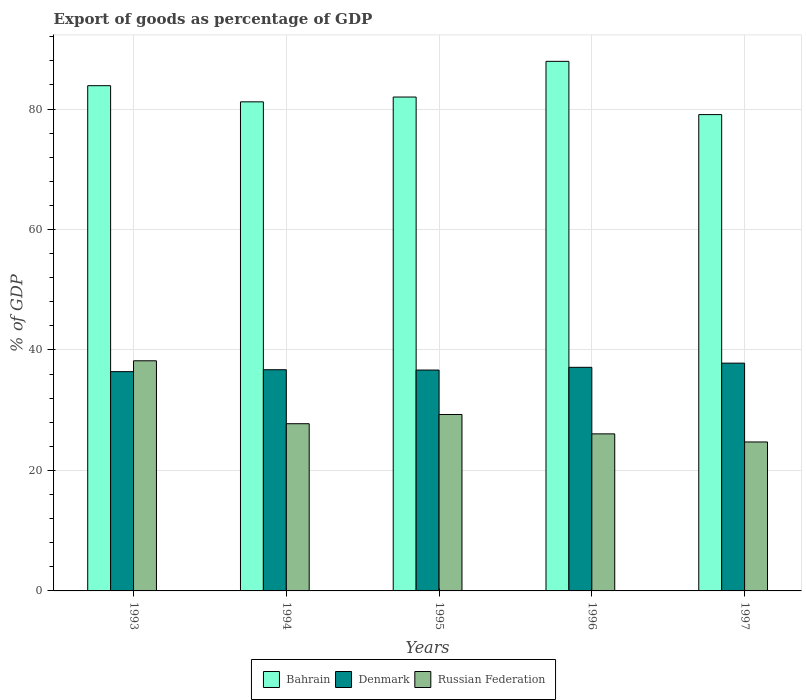How many different coloured bars are there?
Your answer should be very brief. 3. How many groups of bars are there?
Your answer should be compact. 5. What is the export of goods as percentage of GDP in Bahrain in 1993?
Provide a succinct answer. 83.87. Across all years, what is the maximum export of goods as percentage of GDP in Russian Federation?
Ensure brevity in your answer.  38.2. Across all years, what is the minimum export of goods as percentage of GDP in Russian Federation?
Offer a very short reply. 24.73. In which year was the export of goods as percentage of GDP in Denmark minimum?
Give a very brief answer. 1993. What is the total export of goods as percentage of GDP in Bahrain in the graph?
Ensure brevity in your answer.  414.05. What is the difference between the export of goods as percentage of GDP in Bahrain in 1993 and that in 1996?
Ensure brevity in your answer.  -4.04. What is the difference between the export of goods as percentage of GDP in Denmark in 1997 and the export of goods as percentage of GDP in Bahrain in 1995?
Your response must be concise. -44.18. What is the average export of goods as percentage of GDP in Russian Federation per year?
Ensure brevity in your answer.  29.21. In the year 1996, what is the difference between the export of goods as percentage of GDP in Russian Federation and export of goods as percentage of GDP in Denmark?
Offer a very short reply. -11.05. What is the ratio of the export of goods as percentage of GDP in Denmark in 1994 to that in 1997?
Make the answer very short. 0.97. What is the difference between the highest and the second highest export of goods as percentage of GDP in Bahrain?
Provide a succinct answer. 4.04. What is the difference between the highest and the lowest export of goods as percentage of GDP in Russian Federation?
Your response must be concise. 13.47. Is the sum of the export of goods as percentage of GDP in Russian Federation in 1994 and 1996 greater than the maximum export of goods as percentage of GDP in Bahrain across all years?
Offer a very short reply. No. What does the 1st bar from the left in 1996 represents?
Your answer should be compact. Bahrain. What does the 2nd bar from the right in 1996 represents?
Offer a terse response. Denmark. Is it the case that in every year, the sum of the export of goods as percentage of GDP in Denmark and export of goods as percentage of GDP in Bahrain is greater than the export of goods as percentage of GDP in Russian Federation?
Your answer should be compact. Yes. How many bars are there?
Your answer should be very brief. 15. Are all the bars in the graph horizontal?
Provide a succinct answer. No. What is the difference between two consecutive major ticks on the Y-axis?
Offer a terse response. 20. How are the legend labels stacked?
Provide a short and direct response. Horizontal. What is the title of the graph?
Offer a very short reply. Export of goods as percentage of GDP. Does "Singapore" appear as one of the legend labels in the graph?
Your answer should be compact. No. What is the label or title of the Y-axis?
Your response must be concise. % of GDP. What is the % of GDP in Bahrain in 1993?
Your response must be concise. 83.87. What is the % of GDP in Denmark in 1993?
Offer a very short reply. 36.4. What is the % of GDP in Russian Federation in 1993?
Make the answer very short. 38.2. What is the % of GDP of Bahrain in 1994?
Your answer should be very brief. 81.19. What is the % of GDP of Denmark in 1994?
Your response must be concise. 36.72. What is the % of GDP in Russian Federation in 1994?
Offer a terse response. 27.76. What is the % of GDP of Bahrain in 1995?
Your response must be concise. 81.99. What is the % of GDP in Denmark in 1995?
Your response must be concise. 36.67. What is the % of GDP in Russian Federation in 1995?
Your response must be concise. 29.29. What is the % of GDP of Bahrain in 1996?
Make the answer very short. 87.91. What is the % of GDP in Denmark in 1996?
Your answer should be compact. 37.12. What is the % of GDP of Russian Federation in 1996?
Make the answer very short. 26.07. What is the % of GDP in Bahrain in 1997?
Offer a terse response. 79.08. What is the % of GDP of Denmark in 1997?
Your answer should be very brief. 37.81. What is the % of GDP in Russian Federation in 1997?
Ensure brevity in your answer.  24.73. Across all years, what is the maximum % of GDP in Bahrain?
Keep it short and to the point. 87.91. Across all years, what is the maximum % of GDP in Denmark?
Give a very brief answer. 37.81. Across all years, what is the maximum % of GDP in Russian Federation?
Give a very brief answer. 38.2. Across all years, what is the minimum % of GDP in Bahrain?
Make the answer very short. 79.08. Across all years, what is the minimum % of GDP in Denmark?
Provide a short and direct response. 36.4. Across all years, what is the minimum % of GDP in Russian Federation?
Your response must be concise. 24.73. What is the total % of GDP of Bahrain in the graph?
Keep it short and to the point. 414.05. What is the total % of GDP of Denmark in the graph?
Provide a succinct answer. 184.72. What is the total % of GDP of Russian Federation in the graph?
Your answer should be compact. 146.06. What is the difference between the % of GDP of Bahrain in 1993 and that in 1994?
Your answer should be compact. 2.68. What is the difference between the % of GDP of Denmark in 1993 and that in 1994?
Provide a succinct answer. -0.32. What is the difference between the % of GDP in Russian Federation in 1993 and that in 1994?
Your response must be concise. 10.45. What is the difference between the % of GDP of Bahrain in 1993 and that in 1995?
Offer a terse response. 1.88. What is the difference between the % of GDP in Denmark in 1993 and that in 1995?
Make the answer very short. -0.26. What is the difference between the % of GDP in Russian Federation in 1993 and that in 1995?
Give a very brief answer. 8.92. What is the difference between the % of GDP in Bahrain in 1993 and that in 1996?
Your answer should be very brief. -4.04. What is the difference between the % of GDP in Denmark in 1993 and that in 1996?
Give a very brief answer. -0.72. What is the difference between the % of GDP in Russian Federation in 1993 and that in 1996?
Make the answer very short. 12.13. What is the difference between the % of GDP in Bahrain in 1993 and that in 1997?
Offer a very short reply. 4.8. What is the difference between the % of GDP in Denmark in 1993 and that in 1997?
Provide a succinct answer. -1.41. What is the difference between the % of GDP of Russian Federation in 1993 and that in 1997?
Make the answer very short. 13.47. What is the difference between the % of GDP in Bahrain in 1994 and that in 1995?
Keep it short and to the point. -0.8. What is the difference between the % of GDP in Denmark in 1994 and that in 1995?
Keep it short and to the point. 0.05. What is the difference between the % of GDP of Russian Federation in 1994 and that in 1995?
Offer a terse response. -1.53. What is the difference between the % of GDP of Bahrain in 1994 and that in 1996?
Provide a short and direct response. -6.72. What is the difference between the % of GDP of Denmark in 1994 and that in 1996?
Provide a short and direct response. -0.4. What is the difference between the % of GDP in Russian Federation in 1994 and that in 1996?
Keep it short and to the point. 1.69. What is the difference between the % of GDP of Bahrain in 1994 and that in 1997?
Give a very brief answer. 2.12. What is the difference between the % of GDP of Denmark in 1994 and that in 1997?
Your answer should be compact. -1.09. What is the difference between the % of GDP in Russian Federation in 1994 and that in 1997?
Your response must be concise. 3.03. What is the difference between the % of GDP of Bahrain in 1995 and that in 1996?
Your answer should be compact. -5.92. What is the difference between the % of GDP in Denmark in 1995 and that in 1996?
Offer a very short reply. -0.45. What is the difference between the % of GDP of Russian Federation in 1995 and that in 1996?
Offer a very short reply. 3.22. What is the difference between the % of GDP of Bahrain in 1995 and that in 1997?
Provide a succinct answer. 2.91. What is the difference between the % of GDP in Denmark in 1995 and that in 1997?
Keep it short and to the point. -1.15. What is the difference between the % of GDP of Russian Federation in 1995 and that in 1997?
Provide a succinct answer. 4.56. What is the difference between the % of GDP in Bahrain in 1996 and that in 1997?
Give a very brief answer. 8.84. What is the difference between the % of GDP of Denmark in 1996 and that in 1997?
Make the answer very short. -0.69. What is the difference between the % of GDP in Russian Federation in 1996 and that in 1997?
Keep it short and to the point. 1.34. What is the difference between the % of GDP of Bahrain in 1993 and the % of GDP of Denmark in 1994?
Your response must be concise. 47.16. What is the difference between the % of GDP of Bahrain in 1993 and the % of GDP of Russian Federation in 1994?
Offer a terse response. 56.12. What is the difference between the % of GDP of Denmark in 1993 and the % of GDP of Russian Federation in 1994?
Your answer should be very brief. 8.64. What is the difference between the % of GDP in Bahrain in 1993 and the % of GDP in Denmark in 1995?
Your answer should be compact. 47.21. What is the difference between the % of GDP in Bahrain in 1993 and the % of GDP in Russian Federation in 1995?
Offer a very short reply. 54.59. What is the difference between the % of GDP in Denmark in 1993 and the % of GDP in Russian Federation in 1995?
Provide a short and direct response. 7.11. What is the difference between the % of GDP in Bahrain in 1993 and the % of GDP in Denmark in 1996?
Your response must be concise. 46.76. What is the difference between the % of GDP in Bahrain in 1993 and the % of GDP in Russian Federation in 1996?
Give a very brief answer. 57.8. What is the difference between the % of GDP in Denmark in 1993 and the % of GDP in Russian Federation in 1996?
Give a very brief answer. 10.33. What is the difference between the % of GDP of Bahrain in 1993 and the % of GDP of Denmark in 1997?
Your answer should be compact. 46.06. What is the difference between the % of GDP in Bahrain in 1993 and the % of GDP in Russian Federation in 1997?
Your answer should be very brief. 59.14. What is the difference between the % of GDP of Denmark in 1993 and the % of GDP of Russian Federation in 1997?
Provide a short and direct response. 11.67. What is the difference between the % of GDP in Bahrain in 1994 and the % of GDP in Denmark in 1995?
Ensure brevity in your answer.  44.53. What is the difference between the % of GDP in Bahrain in 1994 and the % of GDP in Russian Federation in 1995?
Offer a very short reply. 51.9. What is the difference between the % of GDP of Denmark in 1994 and the % of GDP of Russian Federation in 1995?
Provide a short and direct response. 7.43. What is the difference between the % of GDP in Bahrain in 1994 and the % of GDP in Denmark in 1996?
Offer a very short reply. 44.07. What is the difference between the % of GDP of Bahrain in 1994 and the % of GDP of Russian Federation in 1996?
Your answer should be very brief. 55.12. What is the difference between the % of GDP in Denmark in 1994 and the % of GDP in Russian Federation in 1996?
Make the answer very short. 10.65. What is the difference between the % of GDP of Bahrain in 1994 and the % of GDP of Denmark in 1997?
Make the answer very short. 43.38. What is the difference between the % of GDP in Bahrain in 1994 and the % of GDP in Russian Federation in 1997?
Your answer should be very brief. 56.46. What is the difference between the % of GDP in Denmark in 1994 and the % of GDP in Russian Federation in 1997?
Provide a succinct answer. 11.99. What is the difference between the % of GDP of Bahrain in 1995 and the % of GDP of Denmark in 1996?
Make the answer very short. 44.87. What is the difference between the % of GDP in Bahrain in 1995 and the % of GDP in Russian Federation in 1996?
Offer a terse response. 55.92. What is the difference between the % of GDP in Denmark in 1995 and the % of GDP in Russian Federation in 1996?
Make the answer very short. 10.59. What is the difference between the % of GDP in Bahrain in 1995 and the % of GDP in Denmark in 1997?
Your response must be concise. 44.18. What is the difference between the % of GDP of Bahrain in 1995 and the % of GDP of Russian Federation in 1997?
Your response must be concise. 57.26. What is the difference between the % of GDP in Denmark in 1995 and the % of GDP in Russian Federation in 1997?
Provide a short and direct response. 11.94. What is the difference between the % of GDP of Bahrain in 1996 and the % of GDP of Denmark in 1997?
Your response must be concise. 50.1. What is the difference between the % of GDP of Bahrain in 1996 and the % of GDP of Russian Federation in 1997?
Your response must be concise. 63.18. What is the difference between the % of GDP in Denmark in 1996 and the % of GDP in Russian Federation in 1997?
Provide a short and direct response. 12.39. What is the average % of GDP in Bahrain per year?
Give a very brief answer. 82.81. What is the average % of GDP of Denmark per year?
Your answer should be compact. 36.94. What is the average % of GDP in Russian Federation per year?
Offer a very short reply. 29.21. In the year 1993, what is the difference between the % of GDP in Bahrain and % of GDP in Denmark?
Provide a succinct answer. 47.47. In the year 1993, what is the difference between the % of GDP in Bahrain and % of GDP in Russian Federation?
Your answer should be very brief. 45.67. In the year 1993, what is the difference between the % of GDP of Denmark and % of GDP of Russian Federation?
Your response must be concise. -1.8. In the year 1994, what is the difference between the % of GDP of Bahrain and % of GDP of Denmark?
Offer a very short reply. 44.47. In the year 1994, what is the difference between the % of GDP in Bahrain and % of GDP in Russian Federation?
Give a very brief answer. 53.43. In the year 1994, what is the difference between the % of GDP in Denmark and % of GDP in Russian Federation?
Your response must be concise. 8.96. In the year 1995, what is the difference between the % of GDP of Bahrain and % of GDP of Denmark?
Your answer should be very brief. 45.32. In the year 1995, what is the difference between the % of GDP of Bahrain and % of GDP of Russian Federation?
Provide a short and direct response. 52.7. In the year 1995, what is the difference between the % of GDP in Denmark and % of GDP in Russian Federation?
Make the answer very short. 7.38. In the year 1996, what is the difference between the % of GDP in Bahrain and % of GDP in Denmark?
Give a very brief answer. 50.79. In the year 1996, what is the difference between the % of GDP in Bahrain and % of GDP in Russian Federation?
Ensure brevity in your answer.  61.84. In the year 1996, what is the difference between the % of GDP in Denmark and % of GDP in Russian Federation?
Keep it short and to the point. 11.05. In the year 1997, what is the difference between the % of GDP in Bahrain and % of GDP in Denmark?
Make the answer very short. 41.27. In the year 1997, what is the difference between the % of GDP in Bahrain and % of GDP in Russian Federation?
Give a very brief answer. 54.35. In the year 1997, what is the difference between the % of GDP of Denmark and % of GDP of Russian Federation?
Provide a short and direct response. 13.08. What is the ratio of the % of GDP of Bahrain in 1993 to that in 1994?
Your answer should be compact. 1.03. What is the ratio of the % of GDP of Russian Federation in 1993 to that in 1994?
Your response must be concise. 1.38. What is the ratio of the % of GDP in Bahrain in 1993 to that in 1995?
Offer a very short reply. 1.02. What is the ratio of the % of GDP in Denmark in 1993 to that in 1995?
Give a very brief answer. 0.99. What is the ratio of the % of GDP of Russian Federation in 1993 to that in 1995?
Keep it short and to the point. 1.3. What is the ratio of the % of GDP of Bahrain in 1993 to that in 1996?
Offer a terse response. 0.95. What is the ratio of the % of GDP in Denmark in 1993 to that in 1996?
Make the answer very short. 0.98. What is the ratio of the % of GDP of Russian Federation in 1993 to that in 1996?
Your response must be concise. 1.47. What is the ratio of the % of GDP of Bahrain in 1993 to that in 1997?
Provide a succinct answer. 1.06. What is the ratio of the % of GDP in Denmark in 1993 to that in 1997?
Ensure brevity in your answer.  0.96. What is the ratio of the % of GDP in Russian Federation in 1993 to that in 1997?
Make the answer very short. 1.54. What is the ratio of the % of GDP of Bahrain in 1994 to that in 1995?
Your response must be concise. 0.99. What is the ratio of the % of GDP of Denmark in 1994 to that in 1995?
Provide a short and direct response. 1. What is the ratio of the % of GDP of Russian Federation in 1994 to that in 1995?
Your answer should be very brief. 0.95. What is the ratio of the % of GDP of Bahrain in 1994 to that in 1996?
Ensure brevity in your answer.  0.92. What is the ratio of the % of GDP of Russian Federation in 1994 to that in 1996?
Give a very brief answer. 1.06. What is the ratio of the % of GDP in Bahrain in 1994 to that in 1997?
Make the answer very short. 1.03. What is the ratio of the % of GDP of Denmark in 1994 to that in 1997?
Offer a terse response. 0.97. What is the ratio of the % of GDP in Russian Federation in 1994 to that in 1997?
Make the answer very short. 1.12. What is the ratio of the % of GDP in Bahrain in 1995 to that in 1996?
Keep it short and to the point. 0.93. What is the ratio of the % of GDP in Denmark in 1995 to that in 1996?
Provide a short and direct response. 0.99. What is the ratio of the % of GDP in Russian Federation in 1995 to that in 1996?
Keep it short and to the point. 1.12. What is the ratio of the % of GDP in Bahrain in 1995 to that in 1997?
Your answer should be very brief. 1.04. What is the ratio of the % of GDP in Denmark in 1995 to that in 1997?
Offer a terse response. 0.97. What is the ratio of the % of GDP in Russian Federation in 1995 to that in 1997?
Provide a succinct answer. 1.18. What is the ratio of the % of GDP of Bahrain in 1996 to that in 1997?
Provide a short and direct response. 1.11. What is the ratio of the % of GDP of Denmark in 1996 to that in 1997?
Your answer should be compact. 0.98. What is the ratio of the % of GDP in Russian Federation in 1996 to that in 1997?
Provide a short and direct response. 1.05. What is the difference between the highest and the second highest % of GDP of Bahrain?
Your answer should be very brief. 4.04. What is the difference between the highest and the second highest % of GDP of Denmark?
Keep it short and to the point. 0.69. What is the difference between the highest and the second highest % of GDP in Russian Federation?
Keep it short and to the point. 8.92. What is the difference between the highest and the lowest % of GDP of Bahrain?
Provide a short and direct response. 8.84. What is the difference between the highest and the lowest % of GDP of Denmark?
Offer a very short reply. 1.41. What is the difference between the highest and the lowest % of GDP of Russian Federation?
Offer a terse response. 13.47. 